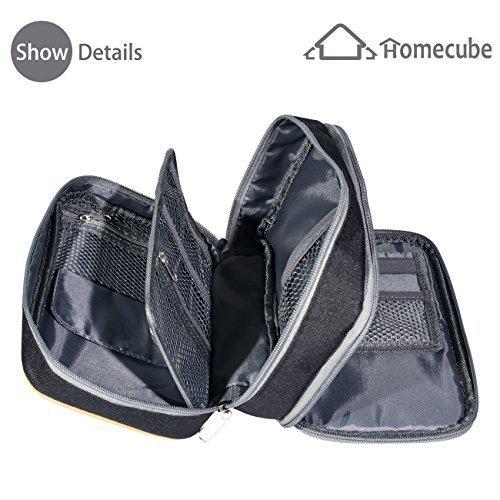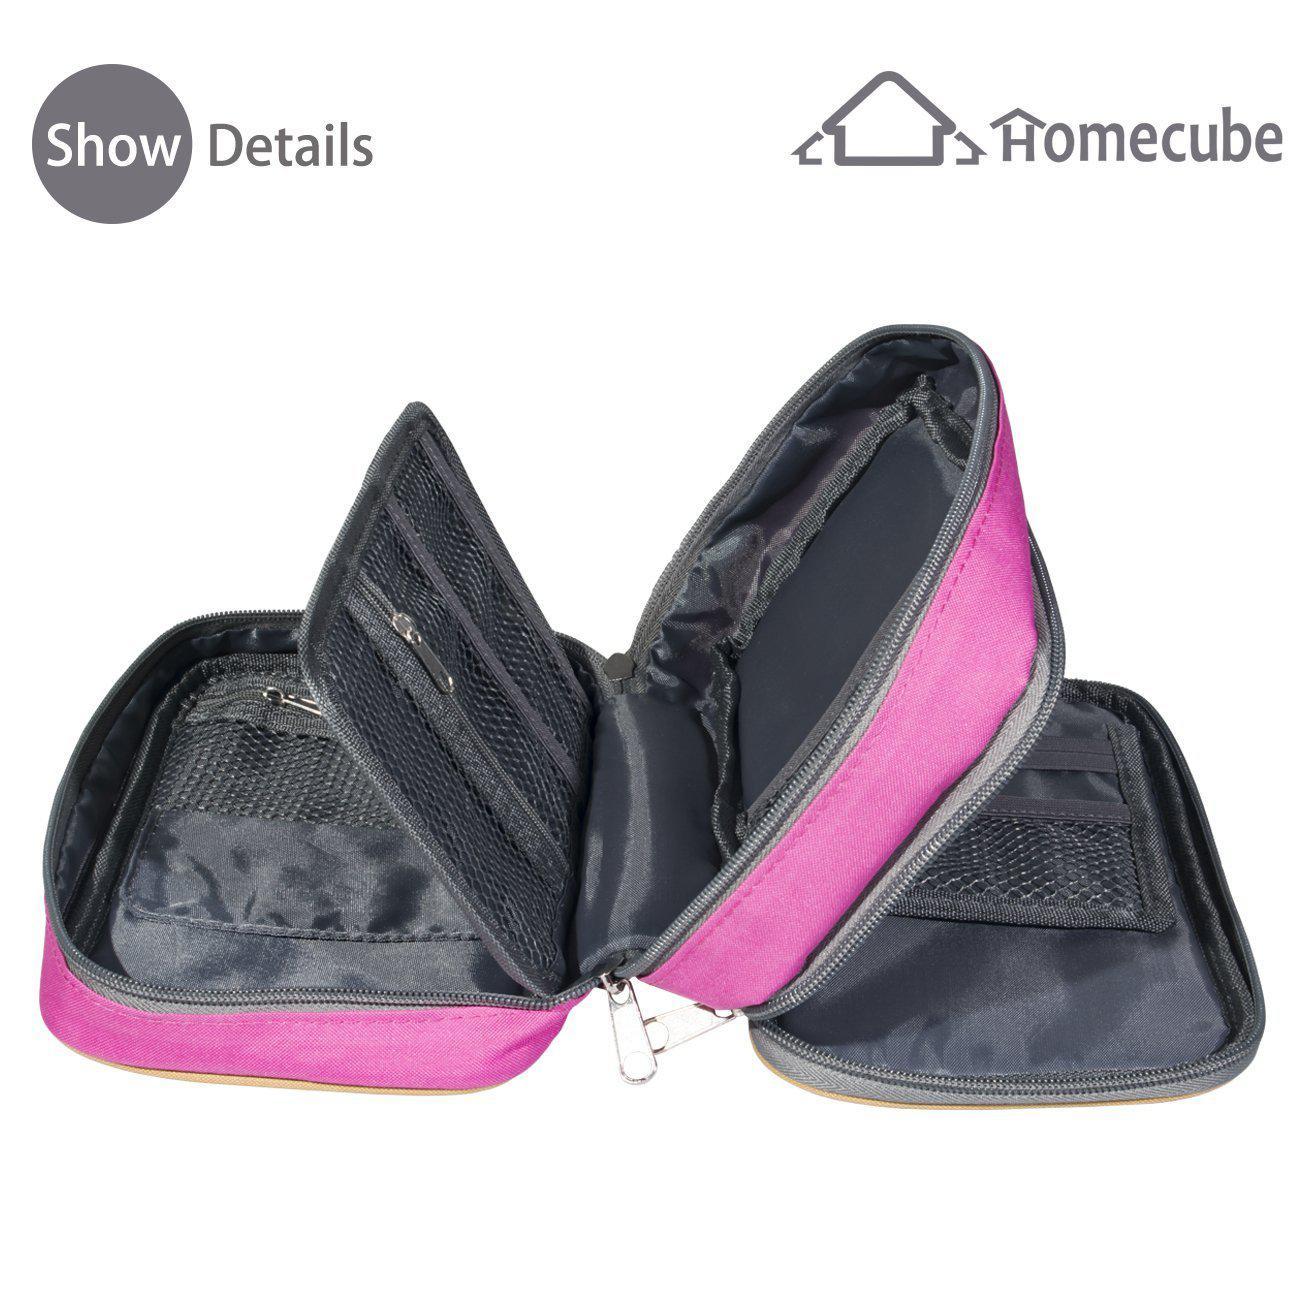The first image is the image on the left, the second image is the image on the right. For the images displayed, is the sentence "Each image shows an open pencil case containing a row of writing implements in a pouch." factually correct? Answer yes or no. No. 